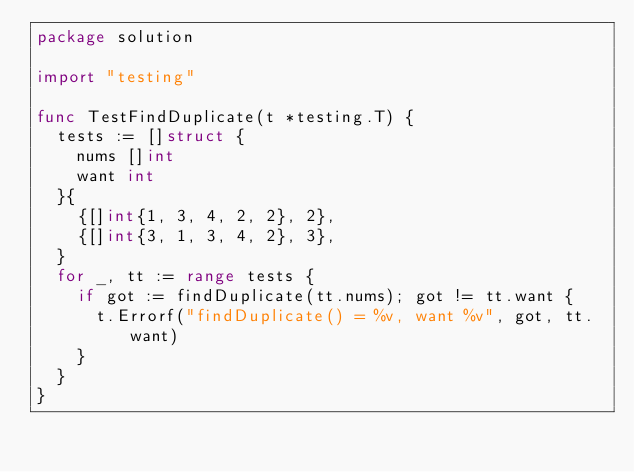<code> <loc_0><loc_0><loc_500><loc_500><_Go_>package solution

import "testing"

func TestFindDuplicate(t *testing.T) {
	tests := []struct {
		nums []int
		want int
	}{
		{[]int{1, 3, 4, 2, 2}, 2},
		{[]int{3, 1, 3, 4, 2}, 3},
	}
	for _, tt := range tests {
		if got := findDuplicate(tt.nums); got != tt.want {
			t.Errorf("findDuplicate() = %v, want %v", got, tt.want)
		}
	}
}
</code> 